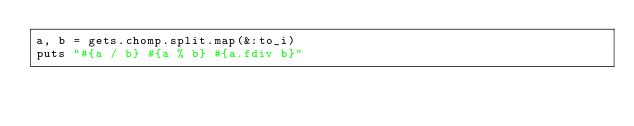<code> <loc_0><loc_0><loc_500><loc_500><_Ruby_>a, b = gets.chomp.split.map(&:to_i)
puts "#{a / b} #{a % b} #{a.fdiv b}"</code> 